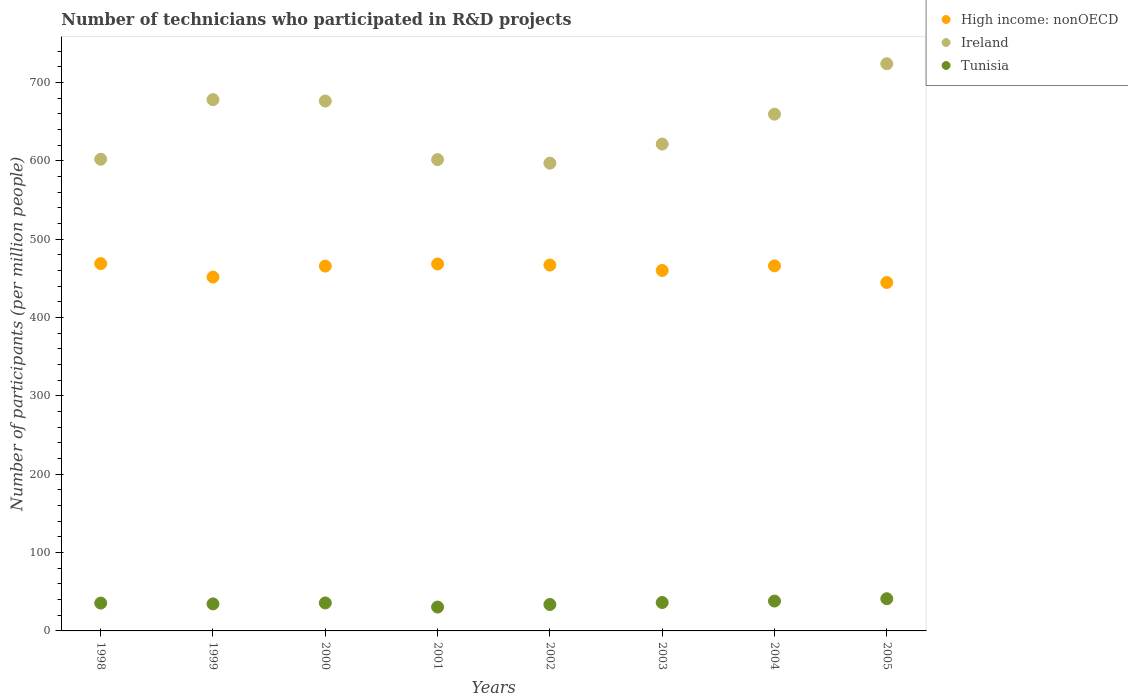Is the number of dotlines equal to the number of legend labels?
Your answer should be very brief. Yes. What is the number of technicians who participated in R&D projects in Tunisia in 1998?
Your answer should be compact. 35.52. Across all years, what is the maximum number of technicians who participated in R&D projects in Tunisia?
Provide a short and direct response. 41.09. Across all years, what is the minimum number of technicians who participated in R&D projects in High income: nonOECD?
Give a very brief answer. 444.7. What is the total number of technicians who participated in R&D projects in Tunisia in the graph?
Your answer should be compact. 285.35. What is the difference between the number of technicians who participated in R&D projects in Ireland in 2000 and that in 2001?
Make the answer very short. 74.75. What is the difference between the number of technicians who participated in R&D projects in High income: nonOECD in 2002 and the number of technicians who participated in R&D projects in Tunisia in 1999?
Offer a terse response. 432.46. What is the average number of technicians who participated in R&D projects in Tunisia per year?
Your response must be concise. 35.67. In the year 2005, what is the difference between the number of technicians who participated in R&D projects in High income: nonOECD and number of technicians who participated in R&D projects in Ireland?
Ensure brevity in your answer.  -279.18. What is the ratio of the number of technicians who participated in R&D projects in Tunisia in 1998 to that in 1999?
Your response must be concise. 1.03. Is the number of technicians who participated in R&D projects in High income: nonOECD in 1999 less than that in 2004?
Your response must be concise. Yes. Is the difference between the number of technicians who participated in R&D projects in High income: nonOECD in 1998 and 2004 greater than the difference between the number of technicians who participated in R&D projects in Ireland in 1998 and 2004?
Your answer should be very brief. Yes. What is the difference between the highest and the second highest number of technicians who participated in R&D projects in High income: nonOECD?
Your answer should be compact. 0.46. What is the difference between the highest and the lowest number of technicians who participated in R&D projects in Tunisia?
Provide a succinct answer. 10.63. In how many years, is the number of technicians who participated in R&D projects in Ireland greater than the average number of technicians who participated in R&D projects in Ireland taken over all years?
Offer a terse response. 4. Is it the case that in every year, the sum of the number of technicians who participated in R&D projects in High income: nonOECD and number of technicians who participated in R&D projects in Tunisia  is greater than the number of technicians who participated in R&D projects in Ireland?
Offer a terse response. No. Does the number of technicians who participated in R&D projects in High income: nonOECD monotonically increase over the years?
Keep it short and to the point. No. Is the number of technicians who participated in R&D projects in Tunisia strictly greater than the number of technicians who participated in R&D projects in High income: nonOECD over the years?
Your response must be concise. No. How many years are there in the graph?
Offer a terse response. 8. What is the difference between two consecutive major ticks on the Y-axis?
Keep it short and to the point. 100. Are the values on the major ticks of Y-axis written in scientific E-notation?
Your response must be concise. No. Does the graph contain any zero values?
Keep it short and to the point. No. Where does the legend appear in the graph?
Offer a terse response. Top right. What is the title of the graph?
Your answer should be very brief. Number of technicians who participated in R&D projects. Does "Qatar" appear as one of the legend labels in the graph?
Provide a succinct answer. No. What is the label or title of the Y-axis?
Offer a very short reply. Number of participants (per million people). What is the Number of participants (per million people) in High income: nonOECD in 1998?
Offer a very short reply. 468.78. What is the Number of participants (per million people) in Ireland in 1998?
Offer a very short reply. 602.03. What is the Number of participants (per million people) in Tunisia in 1998?
Your response must be concise. 35.52. What is the Number of participants (per million people) in High income: nonOECD in 1999?
Keep it short and to the point. 451.63. What is the Number of participants (per million people) in Ireland in 1999?
Keep it short and to the point. 678.05. What is the Number of participants (per million people) of Tunisia in 1999?
Offer a very short reply. 34.49. What is the Number of participants (per million people) of High income: nonOECD in 2000?
Give a very brief answer. 465.64. What is the Number of participants (per million people) of Ireland in 2000?
Provide a succinct answer. 676.29. What is the Number of participants (per million people) in Tunisia in 2000?
Give a very brief answer. 35.7. What is the Number of participants (per million people) of High income: nonOECD in 2001?
Keep it short and to the point. 468.32. What is the Number of participants (per million people) of Ireland in 2001?
Ensure brevity in your answer.  601.53. What is the Number of participants (per million people) in Tunisia in 2001?
Your answer should be very brief. 30.46. What is the Number of participants (per million people) of High income: nonOECD in 2002?
Offer a very short reply. 466.95. What is the Number of participants (per million people) of Ireland in 2002?
Your response must be concise. 596.99. What is the Number of participants (per million people) of Tunisia in 2002?
Make the answer very short. 33.74. What is the Number of participants (per million people) in High income: nonOECD in 2003?
Provide a succinct answer. 460.06. What is the Number of participants (per million people) of Ireland in 2003?
Provide a succinct answer. 621.38. What is the Number of participants (per million people) of Tunisia in 2003?
Give a very brief answer. 36.25. What is the Number of participants (per million people) of High income: nonOECD in 2004?
Your answer should be very brief. 465.98. What is the Number of participants (per million people) in Ireland in 2004?
Ensure brevity in your answer.  659.5. What is the Number of participants (per million people) of Tunisia in 2004?
Make the answer very short. 38.1. What is the Number of participants (per million people) in High income: nonOECD in 2005?
Offer a terse response. 444.7. What is the Number of participants (per million people) in Ireland in 2005?
Keep it short and to the point. 723.89. What is the Number of participants (per million people) of Tunisia in 2005?
Make the answer very short. 41.09. Across all years, what is the maximum Number of participants (per million people) of High income: nonOECD?
Ensure brevity in your answer.  468.78. Across all years, what is the maximum Number of participants (per million people) of Ireland?
Your answer should be compact. 723.89. Across all years, what is the maximum Number of participants (per million people) in Tunisia?
Offer a terse response. 41.09. Across all years, what is the minimum Number of participants (per million people) in High income: nonOECD?
Your answer should be very brief. 444.7. Across all years, what is the minimum Number of participants (per million people) in Ireland?
Give a very brief answer. 596.99. Across all years, what is the minimum Number of participants (per million people) in Tunisia?
Give a very brief answer. 30.46. What is the total Number of participants (per million people) in High income: nonOECD in the graph?
Your response must be concise. 3692.05. What is the total Number of participants (per million people) of Ireland in the graph?
Ensure brevity in your answer.  5159.66. What is the total Number of participants (per million people) in Tunisia in the graph?
Make the answer very short. 285.35. What is the difference between the Number of participants (per million people) of High income: nonOECD in 1998 and that in 1999?
Your response must be concise. 17.15. What is the difference between the Number of participants (per million people) in Ireland in 1998 and that in 1999?
Your response must be concise. -76.02. What is the difference between the Number of participants (per million people) in Tunisia in 1998 and that in 1999?
Your answer should be very brief. 1.03. What is the difference between the Number of participants (per million people) in High income: nonOECD in 1998 and that in 2000?
Offer a very short reply. 3.14. What is the difference between the Number of participants (per million people) of Ireland in 1998 and that in 2000?
Make the answer very short. -74.26. What is the difference between the Number of participants (per million people) in Tunisia in 1998 and that in 2000?
Offer a terse response. -0.18. What is the difference between the Number of participants (per million people) in High income: nonOECD in 1998 and that in 2001?
Your answer should be compact. 0.46. What is the difference between the Number of participants (per million people) of Ireland in 1998 and that in 2001?
Make the answer very short. 0.49. What is the difference between the Number of participants (per million people) of Tunisia in 1998 and that in 2001?
Your answer should be very brief. 5.06. What is the difference between the Number of participants (per million people) in High income: nonOECD in 1998 and that in 2002?
Ensure brevity in your answer.  1.83. What is the difference between the Number of participants (per million people) of Ireland in 1998 and that in 2002?
Make the answer very short. 5.03. What is the difference between the Number of participants (per million people) in Tunisia in 1998 and that in 2002?
Provide a short and direct response. 1.77. What is the difference between the Number of participants (per million people) in High income: nonOECD in 1998 and that in 2003?
Provide a succinct answer. 8.72. What is the difference between the Number of participants (per million people) in Ireland in 1998 and that in 2003?
Make the answer very short. -19.36. What is the difference between the Number of participants (per million people) of Tunisia in 1998 and that in 2003?
Offer a terse response. -0.74. What is the difference between the Number of participants (per million people) in High income: nonOECD in 1998 and that in 2004?
Ensure brevity in your answer.  2.8. What is the difference between the Number of participants (per million people) of Ireland in 1998 and that in 2004?
Provide a succinct answer. -57.48. What is the difference between the Number of participants (per million people) of Tunisia in 1998 and that in 2004?
Make the answer very short. -2.58. What is the difference between the Number of participants (per million people) of High income: nonOECD in 1998 and that in 2005?
Offer a very short reply. 24.08. What is the difference between the Number of participants (per million people) in Ireland in 1998 and that in 2005?
Make the answer very short. -121.86. What is the difference between the Number of participants (per million people) in Tunisia in 1998 and that in 2005?
Your response must be concise. -5.57. What is the difference between the Number of participants (per million people) of High income: nonOECD in 1999 and that in 2000?
Offer a very short reply. -14. What is the difference between the Number of participants (per million people) of Ireland in 1999 and that in 2000?
Provide a short and direct response. 1.76. What is the difference between the Number of participants (per million people) in Tunisia in 1999 and that in 2000?
Keep it short and to the point. -1.2. What is the difference between the Number of participants (per million people) in High income: nonOECD in 1999 and that in 2001?
Give a very brief answer. -16.69. What is the difference between the Number of participants (per million people) in Ireland in 1999 and that in 2001?
Provide a succinct answer. 76.51. What is the difference between the Number of participants (per million people) in Tunisia in 1999 and that in 2001?
Keep it short and to the point. 4.03. What is the difference between the Number of participants (per million people) of High income: nonOECD in 1999 and that in 2002?
Keep it short and to the point. -15.32. What is the difference between the Number of participants (per million people) in Ireland in 1999 and that in 2002?
Make the answer very short. 81.05. What is the difference between the Number of participants (per million people) of Tunisia in 1999 and that in 2002?
Your response must be concise. 0.75. What is the difference between the Number of participants (per million people) of High income: nonOECD in 1999 and that in 2003?
Provide a short and direct response. -8.42. What is the difference between the Number of participants (per million people) of Ireland in 1999 and that in 2003?
Your answer should be compact. 56.67. What is the difference between the Number of participants (per million people) of Tunisia in 1999 and that in 2003?
Keep it short and to the point. -1.76. What is the difference between the Number of participants (per million people) of High income: nonOECD in 1999 and that in 2004?
Your response must be concise. -14.34. What is the difference between the Number of participants (per million people) of Ireland in 1999 and that in 2004?
Offer a terse response. 18.55. What is the difference between the Number of participants (per million people) in Tunisia in 1999 and that in 2004?
Provide a succinct answer. -3.61. What is the difference between the Number of participants (per million people) of High income: nonOECD in 1999 and that in 2005?
Offer a terse response. 6.93. What is the difference between the Number of participants (per million people) in Ireland in 1999 and that in 2005?
Your answer should be compact. -45.84. What is the difference between the Number of participants (per million people) of Tunisia in 1999 and that in 2005?
Keep it short and to the point. -6.6. What is the difference between the Number of participants (per million people) of High income: nonOECD in 2000 and that in 2001?
Offer a very short reply. -2.69. What is the difference between the Number of participants (per million people) in Ireland in 2000 and that in 2001?
Offer a terse response. 74.75. What is the difference between the Number of participants (per million people) in Tunisia in 2000 and that in 2001?
Keep it short and to the point. 5.24. What is the difference between the Number of participants (per million people) in High income: nonOECD in 2000 and that in 2002?
Make the answer very short. -1.31. What is the difference between the Number of participants (per million people) of Ireland in 2000 and that in 2002?
Offer a very short reply. 79.29. What is the difference between the Number of participants (per million people) in Tunisia in 2000 and that in 2002?
Make the answer very short. 1.95. What is the difference between the Number of participants (per million people) of High income: nonOECD in 2000 and that in 2003?
Your answer should be very brief. 5.58. What is the difference between the Number of participants (per million people) in Ireland in 2000 and that in 2003?
Provide a succinct answer. 54.9. What is the difference between the Number of participants (per million people) in Tunisia in 2000 and that in 2003?
Make the answer very short. -0.56. What is the difference between the Number of participants (per million people) of High income: nonOECD in 2000 and that in 2004?
Offer a very short reply. -0.34. What is the difference between the Number of participants (per million people) of Ireland in 2000 and that in 2004?
Provide a succinct answer. 16.78. What is the difference between the Number of participants (per million people) in Tunisia in 2000 and that in 2004?
Keep it short and to the point. -2.4. What is the difference between the Number of participants (per million people) of High income: nonOECD in 2000 and that in 2005?
Provide a succinct answer. 20.93. What is the difference between the Number of participants (per million people) of Ireland in 2000 and that in 2005?
Ensure brevity in your answer.  -47.6. What is the difference between the Number of participants (per million people) of Tunisia in 2000 and that in 2005?
Your answer should be compact. -5.39. What is the difference between the Number of participants (per million people) of High income: nonOECD in 2001 and that in 2002?
Your answer should be compact. 1.37. What is the difference between the Number of participants (per million people) in Ireland in 2001 and that in 2002?
Ensure brevity in your answer.  4.54. What is the difference between the Number of participants (per million people) in Tunisia in 2001 and that in 2002?
Provide a short and direct response. -3.29. What is the difference between the Number of participants (per million people) of High income: nonOECD in 2001 and that in 2003?
Offer a very short reply. 8.27. What is the difference between the Number of participants (per million people) of Ireland in 2001 and that in 2003?
Ensure brevity in your answer.  -19.85. What is the difference between the Number of participants (per million people) in Tunisia in 2001 and that in 2003?
Keep it short and to the point. -5.79. What is the difference between the Number of participants (per million people) of High income: nonOECD in 2001 and that in 2004?
Your response must be concise. 2.34. What is the difference between the Number of participants (per million people) in Ireland in 2001 and that in 2004?
Your answer should be compact. -57.97. What is the difference between the Number of participants (per million people) in Tunisia in 2001 and that in 2004?
Your response must be concise. -7.64. What is the difference between the Number of participants (per million people) in High income: nonOECD in 2001 and that in 2005?
Your answer should be compact. 23.62. What is the difference between the Number of participants (per million people) of Ireland in 2001 and that in 2005?
Provide a succinct answer. -122.35. What is the difference between the Number of participants (per million people) of Tunisia in 2001 and that in 2005?
Offer a very short reply. -10.63. What is the difference between the Number of participants (per million people) of High income: nonOECD in 2002 and that in 2003?
Ensure brevity in your answer.  6.89. What is the difference between the Number of participants (per million people) in Ireland in 2002 and that in 2003?
Provide a short and direct response. -24.39. What is the difference between the Number of participants (per million people) in Tunisia in 2002 and that in 2003?
Ensure brevity in your answer.  -2.51. What is the difference between the Number of participants (per million people) of High income: nonOECD in 2002 and that in 2004?
Offer a terse response. 0.97. What is the difference between the Number of participants (per million people) of Ireland in 2002 and that in 2004?
Your answer should be compact. -62.51. What is the difference between the Number of participants (per million people) of Tunisia in 2002 and that in 2004?
Ensure brevity in your answer.  -4.36. What is the difference between the Number of participants (per million people) of High income: nonOECD in 2002 and that in 2005?
Keep it short and to the point. 22.25. What is the difference between the Number of participants (per million people) in Ireland in 2002 and that in 2005?
Your answer should be compact. -126.89. What is the difference between the Number of participants (per million people) in Tunisia in 2002 and that in 2005?
Your answer should be very brief. -7.34. What is the difference between the Number of participants (per million people) of High income: nonOECD in 2003 and that in 2004?
Offer a terse response. -5.92. What is the difference between the Number of participants (per million people) in Ireland in 2003 and that in 2004?
Give a very brief answer. -38.12. What is the difference between the Number of participants (per million people) of Tunisia in 2003 and that in 2004?
Your response must be concise. -1.85. What is the difference between the Number of participants (per million people) in High income: nonOECD in 2003 and that in 2005?
Provide a short and direct response. 15.35. What is the difference between the Number of participants (per million people) of Ireland in 2003 and that in 2005?
Your response must be concise. -102.5. What is the difference between the Number of participants (per million people) of Tunisia in 2003 and that in 2005?
Offer a terse response. -4.84. What is the difference between the Number of participants (per million people) of High income: nonOECD in 2004 and that in 2005?
Ensure brevity in your answer.  21.27. What is the difference between the Number of participants (per million people) in Ireland in 2004 and that in 2005?
Make the answer very short. -64.38. What is the difference between the Number of participants (per million people) in Tunisia in 2004 and that in 2005?
Your answer should be very brief. -2.99. What is the difference between the Number of participants (per million people) of High income: nonOECD in 1998 and the Number of participants (per million people) of Ireland in 1999?
Make the answer very short. -209.27. What is the difference between the Number of participants (per million people) of High income: nonOECD in 1998 and the Number of participants (per million people) of Tunisia in 1999?
Your answer should be compact. 434.29. What is the difference between the Number of participants (per million people) in Ireland in 1998 and the Number of participants (per million people) in Tunisia in 1999?
Make the answer very short. 567.54. What is the difference between the Number of participants (per million people) of High income: nonOECD in 1998 and the Number of participants (per million people) of Ireland in 2000?
Your answer should be compact. -207.51. What is the difference between the Number of participants (per million people) in High income: nonOECD in 1998 and the Number of participants (per million people) in Tunisia in 2000?
Make the answer very short. 433.08. What is the difference between the Number of participants (per million people) of Ireland in 1998 and the Number of participants (per million people) of Tunisia in 2000?
Your response must be concise. 566.33. What is the difference between the Number of participants (per million people) in High income: nonOECD in 1998 and the Number of participants (per million people) in Ireland in 2001?
Give a very brief answer. -132.76. What is the difference between the Number of participants (per million people) of High income: nonOECD in 1998 and the Number of participants (per million people) of Tunisia in 2001?
Keep it short and to the point. 438.32. What is the difference between the Number of participants (per million people) in Ireland in 1998 and the Number of participants (per million people) in Tunisia in 2001?
Provide a short and direct response. 571.57. What is the difference between the Number of participants (per million people) in High income: nonOECD in 1998 and the Number of participants (per million people) in Ireland in 2002?
Offer a terse response. -128.22. What is the difference between the Number of participants (per million people) in High income: nonOECD in 1998 and the Number of participants (per million people) in Tunisia in 2002?
Ensure brevity in your answer.  435.03. What is the difference between the Number of participants (per million people) of Ireland in 1998 and the Number of participants (per million people) of Tunisia in 2002?
Your answer should be compact. 568.28. What is the difference between the Number of participants (per million people) in High income: nonOECD in 1998 and the Number of participants (per million people) in Ireland in 2003?
Offer a terse response. -152.6. What is the difference between the Number of participants (per million people) in High income: nonOECD in 1998 and the Number of participants (per million people) in Tunisia in 2003?
Offer a very short reply. 432.52. What is the difference between the Number of participants (per million people) in Ireland in 1998 and the Number of participants (per million people) in Tunisia in 2003?
Give a very brief answer. 565.77. What is the difference between the Number of participants (per million people) of High income: nonOECD in 1998 and the Number of participants (per million people) of Ireland in 2004?
Make the answer very short. -190.72. What is the difference between the Number of participants (per million people) of High income: nonOECD in 1998 and the Number of participants (per million people) of Tunisia in 2004?
Offer a very short reply. 430.68. What is the difference between the Number of participants (per million people) in Ireland in 1998 and the Number of participants (per million people) in Tunisia in 2004?
Your response must be concise. 563.93. What is the difference between the Number of participants (per million people) in High income: nonOECD in 1998 and the Number of participants (per million people) in Ireland in 2005?
Give a very brief answer. -255.11. What is the difference between the Number of participants (per million people) in High income: nonOECD in 1998 and the Number of participants (per million people) in Tunisia in 2005?
Your answer should be very brief. 427.69. What is the difference between the Number of participants (per million people) of Ireland in 1998 and the Number of participants (per million people) of Tunisia in 2005?
Keep it short and to the point. 560.94. What is the difference between the Number of participants (per million people) of High income: nonOECD in 1999 and the Number of participants (per million people) of Ireland in 2000?
Your answer should be very brief. -224.65. What is the difference between the Number of participants (per million people) in High income: nonOECD in 1999 and the Number of participants (per million people) in Tunisia in 2000?
Provide a short and direct response. 415.94. What is the difference between the Number of participants (per million people) in Ireland in 1999 and the Number of participants (per million people) in Tunisia in 2000?
Ensure brevity in your answer.  642.35. What is the difference between the Number of participants (per million people) of High income: nonOECD in 1999 and the Number of participants (per million people) of Ireland in 2001?
Make the answer very short. -149.9. What is the difference between the Number of participants (per million people) of High income: nonOECD in 1999 and the Number of participants (per million people) of Tunisia in 2001?
Make the answer very short. 421.17. What is the difference between the Number of participants (per million people) of Ireland in 1999 and the Number of participants (per million people) of Tunisia in 2001?
Offer a very short reply. 647.59. What is the difference between the Number of participants (per million people) of High income: nonOECD in 1999 and the Number of participants (per million people) of Ireland in 2002?
Give a very brief answer. -145.36. What is the difference between the Number of participants (per million people) of High income: nonOECD in 1999 and the Number of participants (per million people) of Tunisia in 2002?
Your response must be concise. 417.89. What is the difference between the Number of participants (per million people) in Ireland in 1999 and the Number of participants (per million people) in Tunisia in 2002?
Your answer should be very brief. 644.3. What is the difference between the Number of participants (per million people) in High income: nonOECD in 1999 and the Number of participants (per million people) in Ireland in 2003?
Keep it short and to the point. -169.75. What is the difference between the Number of participants (per million people) of High income: nonOECD in 1999 and the Number of participants (per million people) of Tunisia in 2003?
Provide a succinct answer. 415.38. What is the difference between the Number of participants (per million people) in Ireland in 1999 and the Number of participants (per million people) in Tunisia in 2003?
Offer a very short reply. 641.79. What is the difference between the Number of participants (per million people) of High income: nonOECD in 1999 and the Number of participants (per million people) of Ireland in 2004?
Your response must be concise. -207.87. What is the difference between the Number of participants (per million people) in High income: nonOECD in 1999 and the Number of participants (per million people) in Tunisia in 2004?
Offer a terse response. 413.53. What is the difference between the Number of participants (per million people) of Ireland in 1999 and the Number of participants (per million people) of Tunisia in 2004?
Make the answer very short. 639.95. What is the difference between the Number of participants (per million people) of High income: nonOECD in 1999 and the Number of participants (per million people) of Ireland in 2005?
Keep it short and to the point. -272.25. What is the difference between the Number of participants (per million people) in High income: nonOECD in 1999 and the Number of participants (per million people) in Tunisia in 2005?
Your response must be concise. 410.54. What is the difference between the Number of participants (per million people) in Ireland in 1999 and the Number of participants (per million people) in Tunisia in 2005?
Provide a succinct answer. 636.96. What is the difference between the Number of participants (per million people) in High income: nonOECD in 2000 and the Number of participants (per million people) in Ireland in 2001?
Keep it short and to the point. -135.9. What is the difference between the Number of participants (per million people) in High income: nonOECD in 2000 and the Number of participants (per million people) in Tunisia in 2001?
Provide a succinct answer. 435.18. What is the difference between the Number of participants (per million people) of Ireland in 2000 and the Number of participants (per million people) of Tunisia in 2001?
Make the answer very short. 645.83. What is the difference between the Number of participants (per million people) in High income: nonOECD in 2000 and the Number of participants (per million people) in Ireland in 2002?
Make the answer very short. -131.36. What is the difference between the Number of participants (per million people) in High income: nonOECD in 2000 and the Number of participants (per million people) in Tunisia in 2002?
Provide a succinct answer. 431.89. What is the difference between the Number of participants (per million people) in Ireland in 2000 and the Number of participants (per million people) in Tunisia in 2002?
Your answer should be compact. 642.54. What is the difference between the Number of participants (per million people) in High income: nonOECD in 2000 and the Number of participants (per million people) in Ireland in 2003?
Keep it short and to the point. -155.75. What is the difference between the Number of participants (per million people) of High income: nonOECD in 2000 and the Number of participants (per million people) of Tunisia in 2003?
Provide a short and direct response. 429.38. What is the difference between the Number of participants (per million people) in Ireland in 2000 and the Number of participants (per million people) in Tunisia in 2003?
Your response must be concise. 640.03. What is the difference between the Number of participants (per million people) in High income: nonOECD in 2000 and the Number of participants (per million people) in Ireland in 2004?
Offer a very short reply. -193.87. What is the difference between the Number of participants (per million people) in High income: nonOECD in 2000 and the Number of participants (per million people) in Tunisia in 2004?
Offer a very short reply. 427.54. What is the difference between the Number of participants (per million people) of Ireland in 2000 and the Number of participants (per million people) of Tunisia in 2004?
Provide a succinct answer. 638.18. What is the difference between the Number of participants (per million people) of High income: nonOECD in 2000 and the Number of participants (per million people) of Ireland in 2005?
Keep it short and to the point. -258.25. What is the difference between the Number of participants (per million people) of High income: nonOECD in 2000 and the Number of participants (per million people) of Tunisia in 2005?
Your answer should be compact. 424.55. What is the difference between the Number of participants (per million people) of Ireland in 2000 and the Number of participants (per million people) of Tunisia in 2005?
Your response must be concise. 635.2. What is the difference between the Number of participants (per million people) in High income: nonOECD in 2001 and the Number of participants (per million people) in Ireland in 2002?
Offer a terse response. -128.67. What is the difference between the Number of participants (per million people) in High income: nonOECD in 2001 and the Number of participants (per million people) in Tunisia in 2002?
Offer a very short reply. 434.58. What is the difference between the Number of participants (per million people) of Ireland in 2001 and the Number of participants (per million people) of Tunisia in 2002?
Your response must be concise. 567.79. What is the difference between the Number of participants (per million people) in High income: nonOECD in 2001 and the Number of participants (per million people) in Ireland in 2003?
Provide a short and direct response. -153.06. What is the difference between the Number of participants (per million people) of High income: nonOECD in 2001 and the Number of participants (per million people) of Tunisia in 2003?
Provide a succinct answer. 432.07. What is the difference between the Number of participants (per million people) in Ireland in 2001 and the Number of participants (per million people) in Tunisia in 2003?
Your answer should be very brief. 565.28. What is the difference between the Number of participants (per million people) in High income: nonOECD in 2001 and the Number of participants (per million people) in Ireland in 2004?
Keep it short and to the point. -191.18. What is the difference between the Number of participants (per million people) of High income: nonOECD in 2001 and the Number of participants (per million people) of Tunisia in 2004?
Your answer should be compact. 430.22. What is the difference between the Number of participants (per million people) of Ireland in 2001 and the Number of participants (per million people) of Tunisia in 2004?
Give a very brief answer. 563.43. What is the difference between the Number of participants (per million people) of High income: nonOECD in 2001 and the Number of participants (per million people) of Ireland in 2005?
Provide a short and direct response. -255.56. What is the difference between the Number of participants (per million people) of High income: nonOECD in 2001 and the Number of participants (per million people) of Tunisia in 2005?
Your response must be concise. 427.23. What is the difference between the Number of participants (per million people) in Ireland in 2001 and the Number of participants (per million people) in Tunisia in 2005?
Keep it short and to the point. 560.45. What is the difference between the Number of participants (per million people) in High income: nonOECD in 2002 and the Number of participants (per million people) in Ireland in 2003?
Provide a succinct answer. -154.43. What is the difference between the Number of participants (per million people) of High income: nonOECD in 2002 and the Number of participants (per million people) of Tunisia in 2003?
Offer a very short reply. 430.69. What is the difference between the Number of participants (per million people) in Ireland in 2002 and the Number of participants (per million people) in Tunisia in 2003?
Give a very brief answer. 560.74. What is the difference between the Number of participants (per million people) in High income: nonOECD in 2002 and the Number of participants (per million people) in Ireland in 2004?
Give a very brief answer. -192.55. What is the difference between the Number of participants (per million people) of High income: nonOECD in 2002 and the Number of participants (per million people) of Tunisia in 2004?
Keep it short and to the point. 428.85. What is the difference between the Number of participants (per million people) in Ireland in 2002 and the Number of participants (per million people) in Tunisia in 2004?
Your answer should be compact. 558.89. What is the difference between the Number of participants (per million people) in High income: nonOECD in 2002 and the Number of participants (per million people) in Ireland in 2005?
Provide a short and direct response. -256.94. What is the difference between the Number of participants (per million people) of High income: nonOECD in 2002 and the Number of participants (per million people) of Tunisia in 2005?
Provide a succinct answer. 425.86. What is the difference between the Number of participants (per million people) of Ireland in 2002 and the Number of participants (per million people) of Tunisia in 2005?
Provide a succinct answer. 555.91. What is the difference between the Number of participants (per million people) of High income: nonOECD in 2003 and the Number of participants (per million people) of Ireland in 2004?
Provide a short and direct response. -199.45. What is the difference between the Number of participants (per million people) of High income: nonOECD in 2003 and the Number of participants (per million people) of Tunisia in 2004?
Your answer should be compact. 421.95. What is the difference between the Number of participants (per million people) of Ireland in 2003 and the Number of participants (per million people) of Tunisia in 2004?
Your answer should be compact. 583.28. What is the difference between the Number of participants (per million people) in High income: nonOECD in 2003 and the Number of participants (per million people) in Ireland in 2005?
Ensure brevity in your answer.  -263.83. What is the difference between the Number of participants (per million people) in High income: nonOECD in 2003 and the Number of participants (per million people) in Tunisia in 2005?
Offer a terse response. 418.97. What is the difference between the Number of participants (per million people) of Ireland in 2003 and the Number of participants (per million people) of Tunisia in 2005?
Offer a very short reply. 580.29. What is the difference between the Number of participants (per million people) in High income: nonOECD in 2004 and the Number of participants (per million people) in Ireland in 2005?
Keep it short and to the point. -257.91. What is the difference between the Number of participants (per million people) of High income: nonOECD in 2004 and the Number of participants (per million people) of Tunisia in 2005?
Keep it short and to the point. 424.89. What is the difference between the Number of participants (per million people) of Ireland in 2004 and the Number of participants (per million people) of Tunisia in 2005?
Make the answer very short. 618.41. What is the average Number of participants (per million people) of High income: nonOECD per year?
Provide a succinct answer. 461.51. What is the average Number of participants (per million people) in Ireland per year?
Provide a short and direct response. 644.96. What is the average Number of participants (per million people) of Tunisia per year?
Your response must be concise. 35.67. In the year 1998, what is the difference between the Number of participants (per million people) in High income: nonOECD and Number of participants (per million people) in Ireland?
Your answer should be very brief. -133.25. In the year 1998, what is the difference between the Number of participants (per million people) of High income: nonOECD and Number of participants (per million people) of Tunisia?
Keep it short and to the point. 433.26. In the year 1998, what is the difference between the Number of participants (per million people) of Ireland and Number of participants (per million people) of Tunisia?
Give a very brief answer. 566.51. In the year 1999, what is the difference between the Number of participants (per million people) in High income: nonOECD and Number of participants (per million people) in Ireland?
Keep it short and to the point. -226.42. In the year 1999, what is the difference between the Number of participants (per million people) of High income: nonOECD and Number of participants (per million people) of Tunisia?
Offer a terse response. 417.14. In the year 1999, what is the difference between the Number of participants (per million people) of Ireland and Number of participants (per million people) of Tunisia?
Keep it short and to the point. 643.56. In the year 2000, what is the difference between the Number of participants (per million people) in High income: nonOECD and Number of participants (per million people) in Ireland?
Provide a succinct answer. -210.65. In the year 2000, what is the difference between the Number of participants (per million people) in High income: nonOECD and Number of participants (per million people) in Tunisia?
Your answer should be compact. 429.94. In the year 2000, what is the difference between the Number of participants (per million people) in Ireland and Number of participants (per million people) in Tunisia?
Offer a terse response. 640.59. In the year 2001, what is the difference between the Number of participants (per million people) of High income: nonOECD and Number of participants (per million people) of Ireland?
Provide a short and direct response. -133.21. In the year 2001, what is the difference between the Number of participants (per million people) of High income: nonOECD and Number of participants (per million people) of Tunisia?
Keep it short and to the point. 437.86. In the year 2001, what is the difference between the Number of participants (per million people) of Ireland and Number of participants (per million people) of Tunisia?
Provide a short and direct response. 571.07. In the year 2002, what is the difference between the Number of participants (per million people) of High income: nonOECD and Number of participants (per million people) of Ireland?
Offer a terse response. -130.05. In the year 2002, what is the difference between the Number of participants (per million people) in High income: nonOECD and Number of participants (per million people) in Tunisia?
Keep it short and to the point. 433.2. In the year 2002, what is the difference between the Number of participants (per million people) of Ireland and Number of participants (per million people) of Tunisia?
Give a very brief answer. 563.25. In the year 2003, what is the difference between the Number of participants (per million people) of High income: nonOECD and Number of participants (per million people) of Ireland?
Your response must be concise. -161.33. In the year 2003, what is the difference between the Number of participants (per million people) in High income: nonOECD and Number of participants (per million people) in Tunisia?
Keep it short and to the point. 423.8. In the year 2003, what is the difference between the Number of participants (per million people) of Ireland and Number of participants (per million people) of Tunisia?
Your answer should be very brief. 585.13. In the year 2004, what is the difference between the Number of participants (per million people) of High income: nonOECD and Number of participants (per million people) of Ireland?
Provide a succinct answer. -193.53. In the year 2004, what is the difference between the Number of participants (per million people) of High income: nonOECD and Number of participants (per million people) of Tunisia?
Make the answer very short. 427.88. In the year 2004, what is the difference between the Number of participants (per million people) in Ireland and Number of participants (per million people) in Tunisia?
Give a very brief answer. 621.4. In the year 2005, what is the difference between the Number of participants (per million people) of High income: nonOECD and Number of participants (per million people) of Ireland?
Make the answer very short. -279.18. In the year 2005, what is the difference between the Number of participants (per million people) in High income: nonOECD and Number of participants (per million people) in Tunisia?
Provide a succinct answer. 403.61. In the year 2005, what is the difference between the Number of participants (per million people) of Ireland and Number of participants (per million people) of Tunisia?
Keep it short and to the point. 682.8. What is the ratio of the Number of participants (per million people) of High income: nonOECD in 1998 to that in 1999?
Make the answer very short. 1.04. What is the ratio of the Number of participants (per million people) of Ireland in 1998 to that in 1999?
Keep it short and to the point. 0.89. What is the ratio of the Number of participants (per million people) of Tunisia in 1998 to that in 1999?
Offer a terse response. 1.03. What is the ratio of the Number of participants (per million people) in Ireland in 1998 to that in 2000?
Provide a succinct answer. 0.89. What is the ratio of the Number of participants (per million people) in Tunisia in 1998 to that in 2000?
Make the answer very short. 0.99. What is the ratio of the Number of participants (per million people) of High income: nonOECD in 1998 to that in 2001?
Make the answer very short. 1. What is the ratio of the Number of participants (per million people) of Tunisia in 1998 to that in 2001?
Offer a very short reply. 1.17. What is the ratio of the Number of participants (per million people) in Ireland in 1998 to that in 2002?
Your answer should be very brief. 1.01. What is the ratio of the Number of participants (per million people) of Tunisia in 1998 to that in 2002?
Give a very brief answer. 1.05. What is the ratio of the Number of participants (per million people) of High income: nonOECD in 1998 to that in 2003?
Your answer should be compact. 1.02. What is the ratio of the Number of participants (per million people) in Ireland in 1998 to that in 2003?
Offer a very short reply. 0.97. What is the ratio of the Number of participants (per million people) of Tunisia in 1998 to that in 2003?
Offer a terse response. 0.98. What is the ratio of the Number of participants (per million people) in High income: nonOECD in 1998 to that in 2004?
Provide a succinct answer. 1.01. What is the ratio of the Number of participants (per million people) of Ireland in 1998 to that in 2004?
Offer a terse response. 0.91. What is the ratio of the Number of participants (per million people) in Tunisia in 1998 to that in 2004?
Your answer should be compact. 0.93. What is the ratio of the Number of participants (per million people) in High income: nonOECD in 1998 to that in 2005?
Keep it short and to the point. 1.05. What is the ratio of the Number of participants (per million people) of Ireland in 1998 to that in 2005?
Your response must be concise. 0.83. What is the ratio of the Number of participants (per million people) of Tunisia in 1998 to that in 2005?
Offer a terse response. 0.86. What is the ratio of the Number of participants (per million people) in High income: nonOECD in 1999 to that in 2000?
Offer a very short reply. 0.97. What is the ratio of the Number of participants (per million people) of Ireland in 1999 to that in 2000?
Your answer should be compact. 1. What is the ratio of the Number of participants (per million people) of Tunisia in 1999 to that in 2000?
Give a very brief answer. 0.97. What is the ratio of the Number of participants (per million people) of High income: nonOECD in 1999 to that in 2001?
Your response must be concise. 0.96. What is the ratio of the Number of participants (per million people) of Ireland in 1999 to that in 2001?
Keep it short and to the point. 1.13. What is the ratio of the Number of participants (per million people) of Tunisia in 1999 to that in 2001?
Keep it short and to the point. 1.13. What is the ratio of the Number of participants (per million people) in High income: nonOECD in 1999 to that in 2002?
Keep it short and to the point. 0.97. What is the ratio of the Number of participants (per million people) in Ireland in 1999 to that in 2002?
Your answer should be compact. 1.14. What is the ratio of the Number of participants (per million people) in Tunisia in 1999 to that in 2002?
Your answer should be very brief. 1.02. What is the ratio of the Number of participants (per million people) in High income: nonOECD in 1999 to that in 2003?
Give a very brief answer. 0.98. What is the ratio of the Number of participants (per million people) in Ireland in 1999 to that in 2003?
Keep it short and to the point. 1.09. What is the ratio of the Number of participants (per million people) of Tunisia in 1999 to that in 2003?
Your answer should be very brief. 0.95. What is the ratio of the Number of participants (per million people) of High income: nonOECD in 1999 to that in 2004?
Keep it short and to the point. 0.97. What is the ratio of the Number of participants (per million people) of Ireland in 1999 to that in 2004?
Your answer should be compact. 1.03. What is the ratio of the Number of participants (per million people) of Tunisia in 1999 to that in 2004?
Provide a short and direct response. 0.91. What is the ratio of the Number of participants (per million people) in High income: nonOECD in 1999 to that in 2005?
Your answer should be very brief. 1.02. What is the ratio of the Number of participants (per million people) of Ireland in 1999 to that in 2005?
Keep it short and to the point. 0.94. What is the ratio of the Number of participants (per million people) of Tunisia in 1999 to that in 2005?
Give a very brief answer. 0.84. What is the ratio of the Number of participants (per million people) of High income: nonOECD in 2000 to that in 2001?
Give a very brief answer. 0.99. What is the ratio of the Number of participants (per million people) of Ireland in 2000 to that in 2001?
Offer a terse response. 1.12. What is the ratio of the Number of participants (per million people) in Tunisia in 2000 to that in 2001?
Ensure brevity in your answer.  1.17. What is the ratio of the Number of participants (per million people) in Ireland in 2000 to that in 2002?
Your answer should be compact. 1.13. What is the ratio of the Number of participants (per million people) in Tunisia in 2000 to that in 2002?
Ensure brevity in your answer.  1.06. What is the ratio of the Number of participants (per million people) in High income: nonOECD in 2000 to that in 2003?
Your answer should be very brief. 1.01. What is the ratio of the Number of participants (per million people) of Ireland in 2000 to that in 2003?
Your response must be concise. 1.09. What is the ratio of the Number of participants (per million people) of Tunisia in 2000 to that in 2003?
Keep it short and to the point. 0.98. What is the ratio of the Number of participants (per million people) in High income: nonOECD in 2000 to that in 2004?
Give a very brief answer. 1. What is the ratio of the Number of participants (per million people) of Ireland in 2000 to that in 2004?
Offer a terse response. 1.03. What is the ratio of the Number of participants (per million people) of Tunisia in 2000 to that in 2004?
Provide a succinct answer. 0.94. What is the ratio of the Number of participants (per million people) in High income: nonOECD in 2000 to that in 2005?
Make the answer very short. 1.05. What is the ratio of the Number of participants (per million people) in Ireland in 2000 to that in 2005?
Keep it short and to the point. 0.93. What is the ratio of the Number of participants (per million people) of Tunisia in 2000 to that in 2005?
Your answer should be compact. 0.87. What is the ratio of the Number of participants (per million people) in Ireland in 2001 to that in 2002?
Offer a terse response. 1.01. What is the ratio of the Number of participants (per million people) of Tunisia in 2001 to that in 2002?
Make the answer very short. 0.9. What is the ratio of the Number of participants (per million people) of Ireland in 2001 to that in 2003?
Make the answer very short. 0.97. What is the ratio of the Number of participants (per million people) in Tunisia in 2001 to that in 2003?
Provide a succinct answer. 0.84. What is the ratio of the Number of participants (per million people) in Ireland in 2001 to that in 2004?
Provide a short and direct response. 0.91. What is the ratio of the Number of participants (per million people) in Tunisia in 2001 to that in 2004?
Your response must be concise. 0.8. What is the ratio of the Number of participants (per million people) of High income: nonOECD in 2001 to that in 2005?
Ensure brevity in your answer.  1.05. What is the ratio of the Number of participants (per million people) in Ireland in 2001 to that in 2005?
Provide a short and direct response. 0.83. What is the ratio of the Number of participants (per million people) of Tunisia in 2001 to that in 2005?
Your answer should be very brief. 0.74. What is the ratio of the Number of participants (per million people) of Ireland in 2002 to that in 2003?
Your answer should be compact. 0.96. What is the ratio of the Number of participants (per million people) of Tunisia in 2002 to that in 2003?
Ensure brevity in your answer.  0.93. What is the ratio of the Number of participants (per million people) in Ireland in 2002 to that in 2004?
Give a very brief answer. 0.91. What is the ratio of the Number of participants (per million people) in Tunisia in 2002 to that in 2004?
Provide a short and direct response. 0.89. What is the ratio of the Number of participants (per million people) in Ireland in 2002 to that in 2005?
Give a very brief answer. 0.82. What is the ratio of the Number of participants (per million people) in Tunisia in 2002 to that in 2005?
Your answer should be compact. 0.82. What is the ratio of the Number of participants (per million people) in High income: nonOECD in 2003 to that in 2004?
Ensure brevity in your answer.  0.99. What is the ratio of the Number of participants (per million people) of Ireland in 2003 to that in 2004?
Ensure brevity in your answer.  0.94. What is the ratio of the Number of participants (per million people) in Tunisia in 2003 to that in 2004?
Keep it short and to the point. 0.95. What is the ratio of the Number of participants (per million people) of High income: nonOECD in 2003 to that in 2005?
Your response must be concise. 1.03. What is the ratio of the Number of participants (per million people) in Ireland in 2003 to that in 2005?
Your answer should be very brief. 0.86. What is the ratio of the Number of participants (per million people) of Tunisia in 2003 to that in 2005?
Your answer should be compact. 0.88. What is the ratio of the Number of participants (per million people) in High income: nonOECD in 2004 to that in 2005?
Offer a terse response. 1.05. What is the ratio of the Number of participants (per million people) in Ireland in 2004 to that in 2005?
Provide a succinct answer. 0.91. What is the ratio of the Number of participants (per million people) in Tunisia in 2004 to that in 2005?
Offer a very short reply. 0.93. What is the difference between the highest and the second highest Number of participants (per million people) of High income: nonOECD?
Your answer should be very brief. 0.46. What is the difference between the highest and the second highest Number of participants (per million people) of Ireland?
Offer a terse response. 45.84. What is the difference between the highest and the second highest Number of participants (per million people) in Tunisia?
Your answer should be compact. 2.99. What is the difference between the highest and the lowest Number of participants (per million people) in High income: nonOECD?
Give a very brief answer. 24.08. What is the difference between the highest and the lowest Number of participants (per million people) in Ireland?
Offer a very short reply. 126.89. What is the difference between the highest and the lowest Number of participants (per million people) in Tunisia?
Your response must be concise. 10.63. 